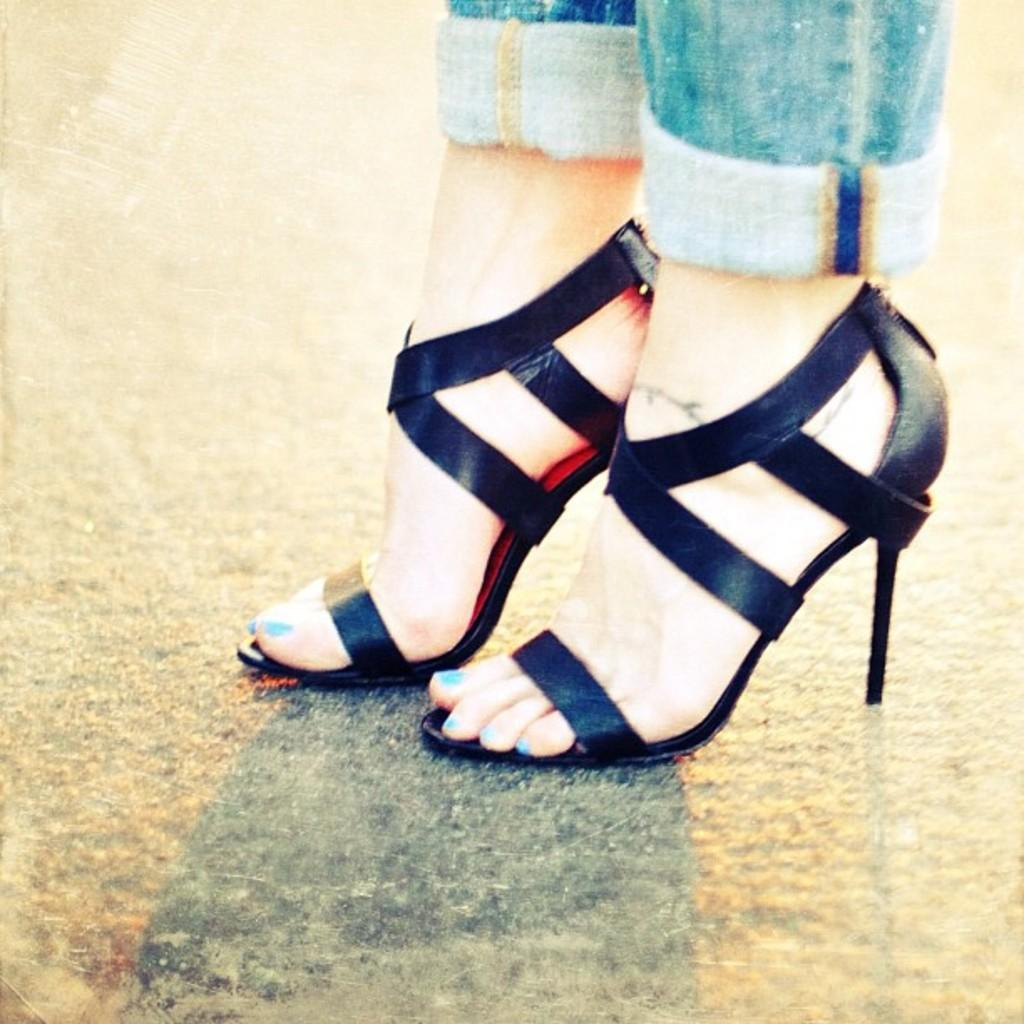Who is the main subject in the image? There is a lady in the center of the image. What type of footwear is the lady wearing? The lady is wearing heels. What can be seen behind the lady in the image? There is a floor visible in the background of the image. Is there a kickboxing match happening in the image? No, there is no kickboxing match or any fighting depicted in the image. The lady is simply standing in the center, wearing heels. 